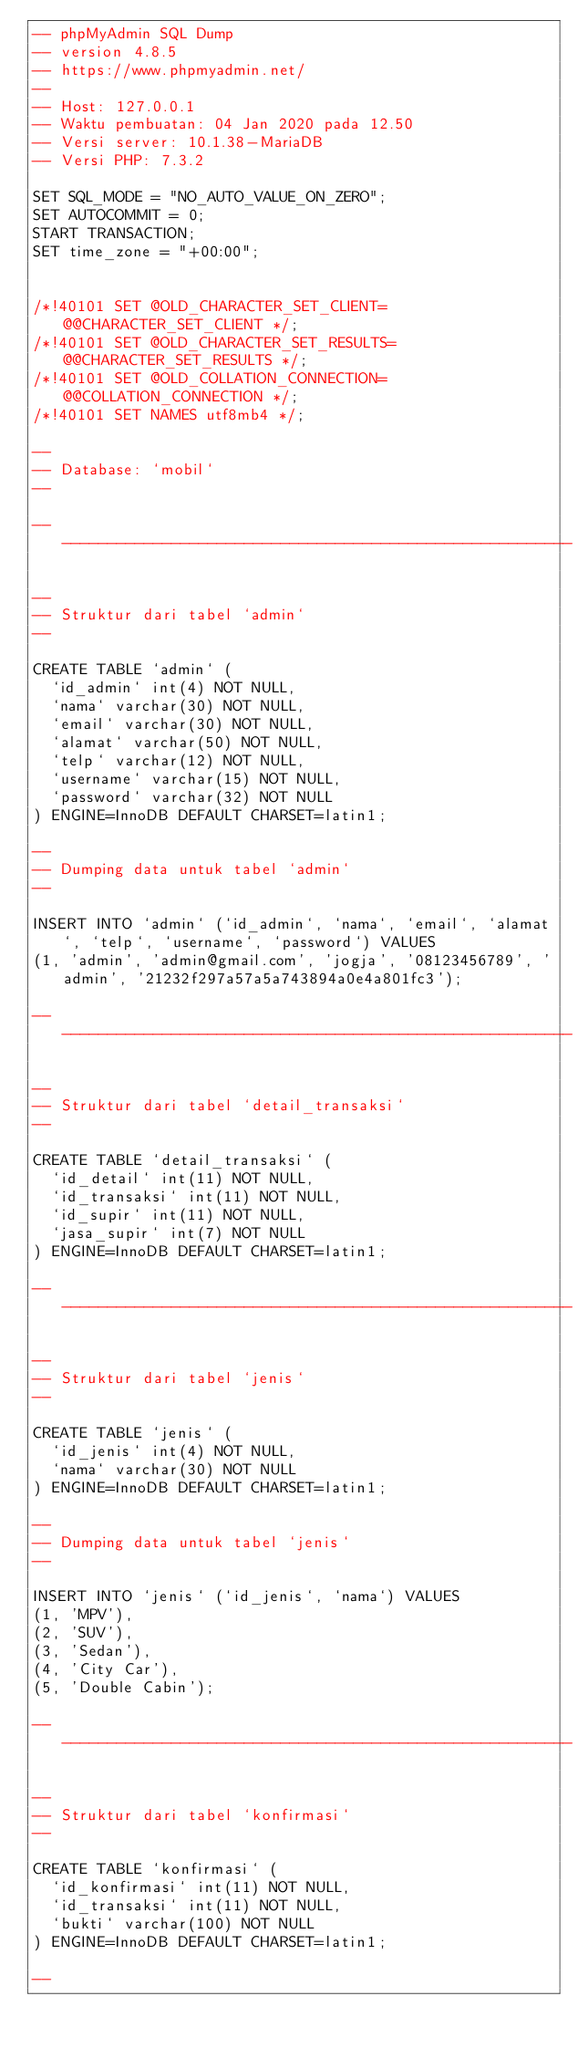Convert code to text. <code><loc_0><loc_0><loc_500><loc_500><_SQL_>-- phpMyAdmin SQL Dump
-- version 4.8.5
-- https://www.phpmyadmin.net/
--
-- Host: 127.0.0.1
-- Waktu pembuatan: 04 Jan 2020 pada 12.50
-- Versi server: 10.1.38-MariaDB
-- Versi PHP: 7.3.2

SET SQL_MODE = "NO_AUTO_VALUE_ON_ZERO";
SET AUTOCOMMIT = 0;
START TRANSACTION;
SET time_zone = "+00:00";


/*!40101 SET @OLD_CHARACTER_SET_CLIENT=@@CHARACTER_SET_CLIENT */;
/*!40101 SET @OLD_CHARACTER_SET_RESULTS=@@CHARACTER_SET_RESULTS */;
/*!40101 SET @OLD_COLLATION_CONNECTION=@@COLLATION_CONNECTION */;
/*!40101 SET NAMES utf8mb4 */;

--
-- Database: `mobil`
--

-- --------------------------------------------------------

--
-- Struktur dari tabel `admin`
--

CREATE TABLE `admin` (
  `id_admin` int(4) NOT NULL,
  `nama` varchar(30) NOT NULL,
  `email` varchar(30) NOT NULL,
  `alamat` varchar(50) NOT NULL,
  `telp` varchar(12) NOT NULL,
  `username` varchar(15) NOT NULL,
  `password` varchar(32) NOT NULL
) ENGINE=InnoDB DEFAULT CHARSET=latin1;

--
-- Dumping data untuk tabel `admin`
--

INSERT INTO `admin` (`id_admin`, `nama`, `email`, `alamat`, `telp`, `username`, `password`) VALUES
(1, 'admin', 'admin@gmail.com', 'jogja', '08123456789', 'admin', '21232f297a57a5a743894a0e4a801fc3');

-- --------------------------------------------------------

--
-- Struktur dari tabel `detail_transaksi`
--

CREATE TABLE `detail_transaksi` (
  `id_detail` int(11) NOT NULL,
  `id_transaksi` int(11) NOT NULL,
  `id_supir` int(11) NOT NULL,
  `jasa_supir` int(7) NOT NULL
) ENGINE=InnoDB DEFAULT CHARSET=latin1;

-- --------------------------------------------------------

--
-- Struktur dari tabel `jenis`
--

CREATE TABLE `jenis` (
  `id_jenis` int(4) NOT NULL,
  `nama` varchar(30) NOT NULL
) ENGINE=InnoDB DEFAULT CHARSET=latin1;

--
-- Dumping data untuk tabel `jenis`
--

INSERT INTO `jenis` (`id_jenis`, `nama`) VALUES
(1, 'MPV'),
(2, 'SUV'),
(3, 'Sedan'),
(4, 'City Car'),
(5, 'Double Cabin');

-- --------------------------------------------------------

--
-- Struktur dari tabel `konfirmasi`
--

CREATE TABLE `konfirmasi` (
  `id_konfirmasi` int(11) NOT NULL,
  `id_transaksi` int(11) NOT NULL,
  `bukti` varchar(100) NOT NULL
) ENGINE=InnoDB DEFAULT CHARSET=latin1;

--</code> 